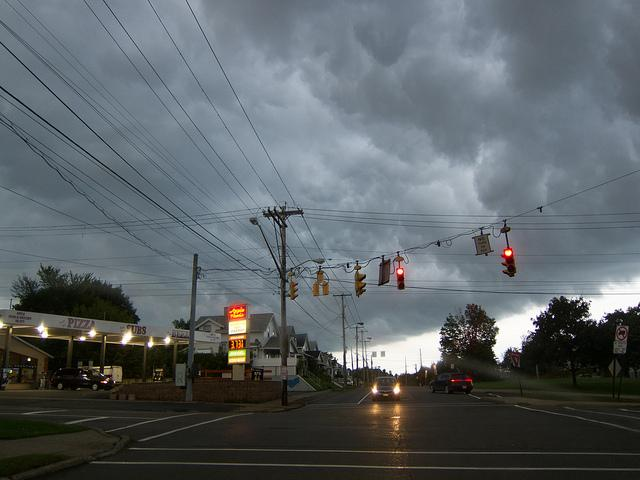What type of station is in view? Please explain your reasoning. gas. A business is on the corner at an intersection and is the only business open at night. 